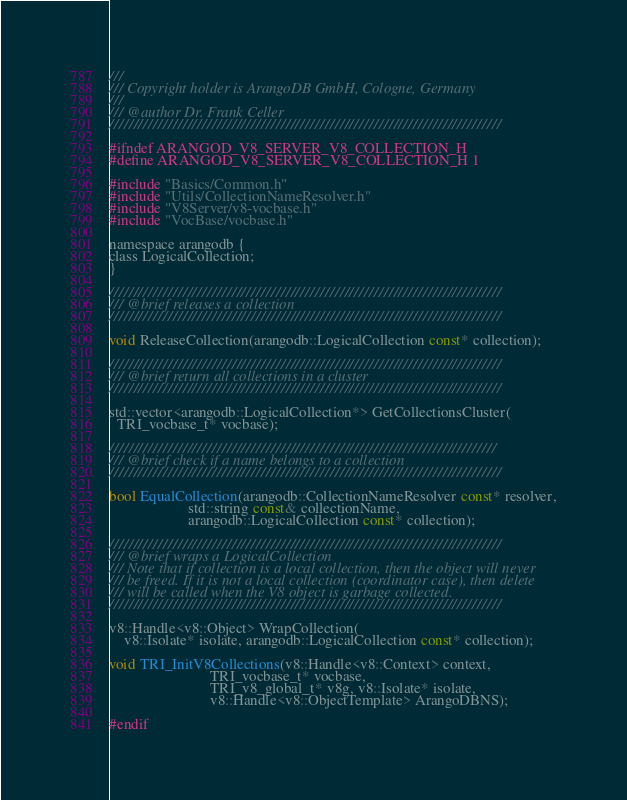Convert code to text. <code><loc_0><loc_0><loc_500><loc_500><_C_>///
/// Copyright holder is ArangoDB GmbH, Cologne, Germany
///
/// @author Dr. Frank Celler
////////////////////////////////////////////////////////////////////////////////

#ifndef ARANGOD_V8_SERVER_V8_COLLECTION_H
#define ARANGOD_V8_SERVER_V8_COLLECTION_H 1

#include "Basics/Common.h"
#include "Utils/CollectionNameResolver.h"
#include "V8Server/v8-vocbase.h"
#include "VocBase/vocbase.h"

namespace arangodb {
class LogicalCollection;
}

////////////////////////////////////////////////////////////////////////////////
/// @brief releases a collection
////////////////////////////////////////////////////////////////////////////////

void ReleaseCollection(arangodb::LogicalCollection const* collection);

////////////////////////////////////////////////////////////////////////////////
/// @brief return all collections in a cluster
////////////////////////////////////////////////////////////////////////////////

std::vector<arangodb::LogicalCollection*> GetCollectionsCluster(
  TRI_vocbase_t* vocbase);

///////////////////////////////////////////////////////////////////////////////
/// @brief check if a name belongs to a collection
////////////////////////////////////////////////////////////////////////////////

bool EqualCollection(arangodb::CollectionNameResolver const* resolver,
                     std::string const& collectionName,
                     arangodb::LogicalCollection const* collection);

////////////////////////////////////////////////////////////////////////////////
/// @brief wraps a LogicalCollection
/// Note that if collection is a local collection, then the object will never
/// be freed. If it is not a local collection (coordinator case), then delete
/// will be called when the V8 object is garbage collected.
////////////////////////////////////////////////////////////////////////////////

v8::Handle<v8::Object> WrapCollection(
    v8::Isolate* isolate, arangodb::LogicalCollection const* collection);

void TRI_InitV8Collections(v8::Handle<v8::Context> context,
                           TRI_vocbase_t* vocbase, 
                           TRI_v8_global_t* v8g, v8::Isolate* isolate,
                           v8::Handle<v8::ObjectTemplate> ArangoDBNS);

#endif
</code> 